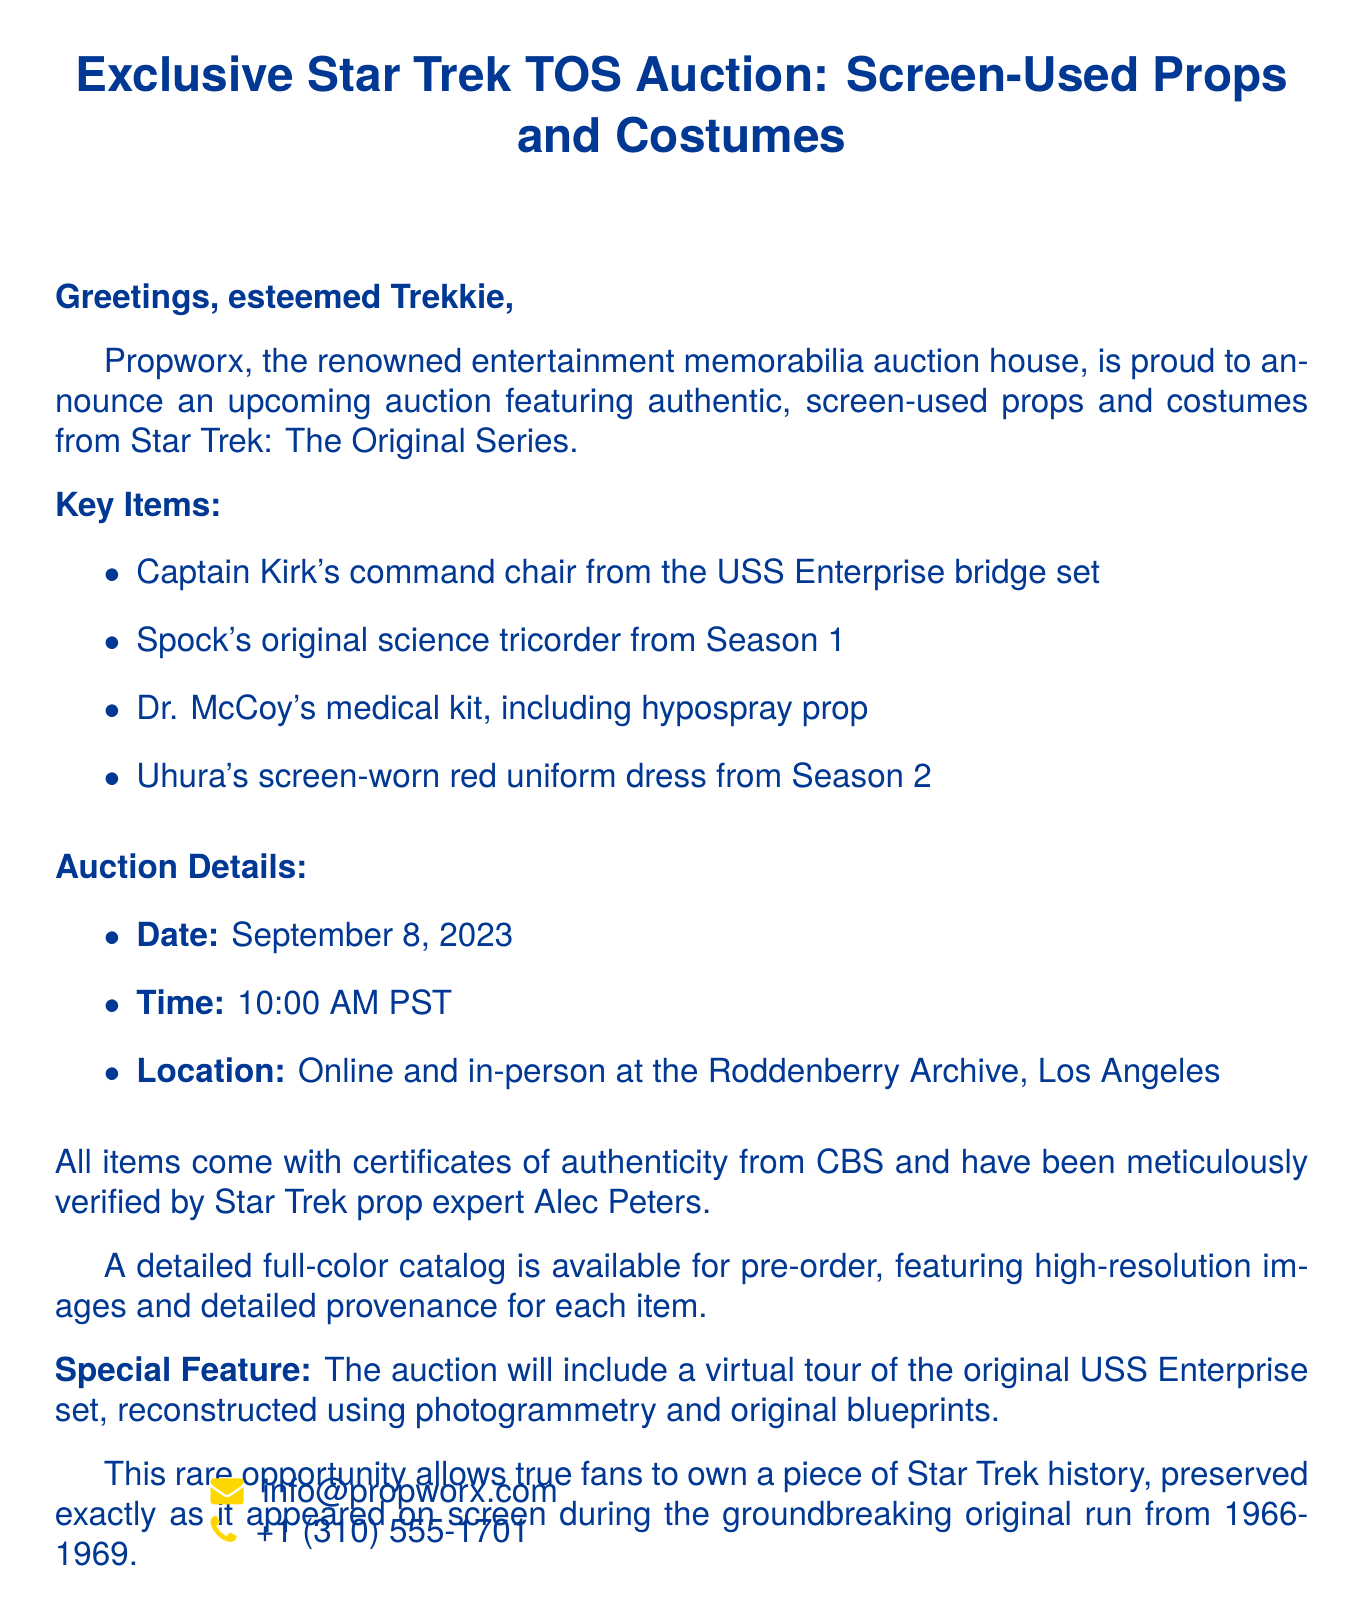What day is the auction scheduled for? The auction date is explicitly stated in the document.
Answer: September 8, 2023 What item belonged to Captain Kirk? The document lists the key items, including the one specifically associated with Captain Kirk.
Answer: Captain Kirk's command chair What special feature is included in the auction? The document mentions a unique element of the auction that involves the USS Enterprise set.
Answer: Virtual tour of the original USS Enterprise set Who verified the authenticity of the items? The document specifies an expert responsible for verifying the authenticity of the auction items.
Answer: Alec Peters What time does the auction start? The starting time for the auction is clearly stated in the document.
Answer: 10:00 AM PST 